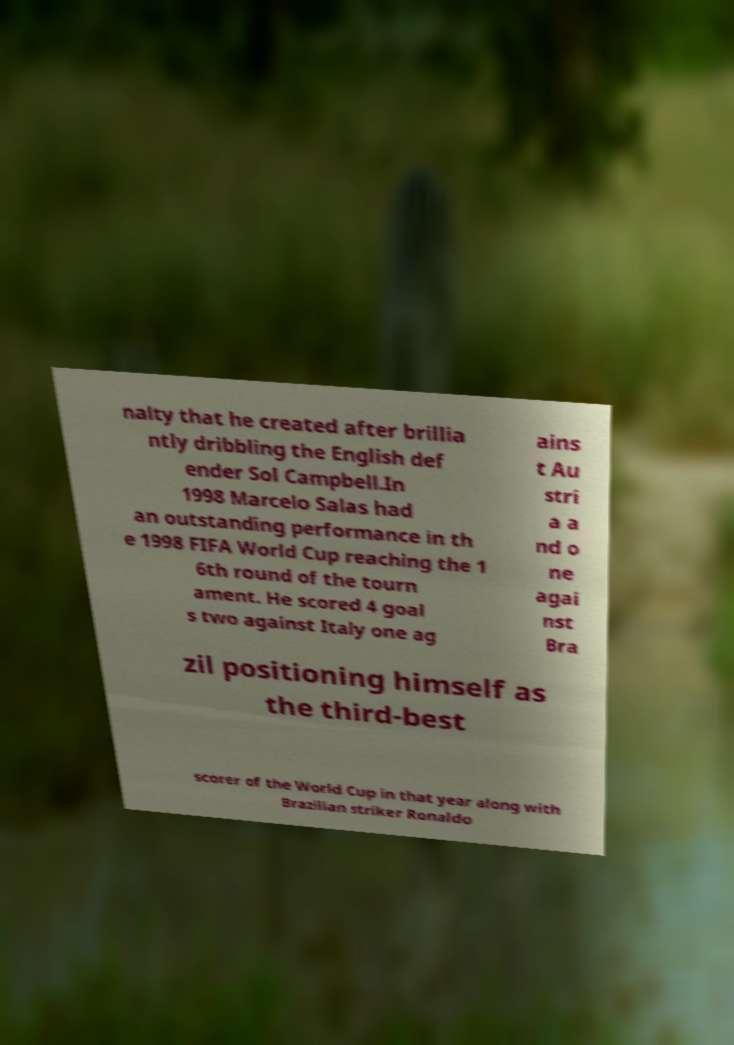Can you read and provide the text displayed in the image?This photo seems to have some interesting text. Can you extract and type it out for me? nalty that he created after brillia ntly dribbling the English def ender Sol Campbell.In 1998 Marcelo Salas had an outstanding performance in th e 1998 FIFA World Cup reaching the 1 6th round of the tourn ament. He scored 4 goal s two against Italy one ag ains t Au stri a a nd o ne agai nst Bra zil positioning himself as the third-best scorer of the World Cup in that year along with Brazilian striker Ronaldo 